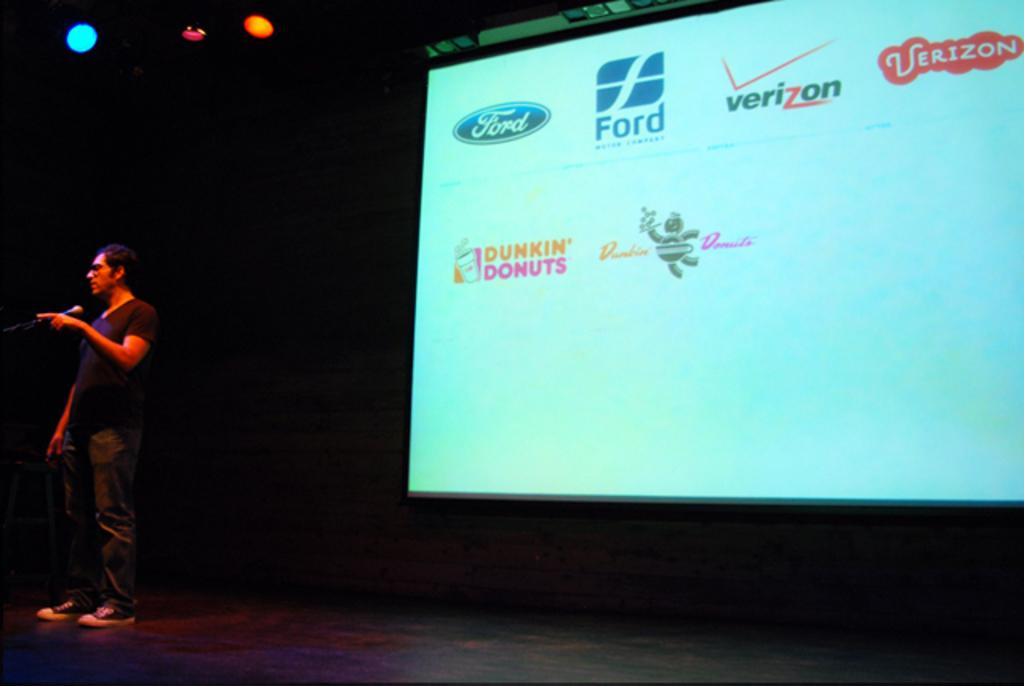<image>
Provide a brief description of the given image. A man is on a stage in front of a screen that has several brand icons, including Ford, Verizon, and Dunkin' Donuts, on it. 